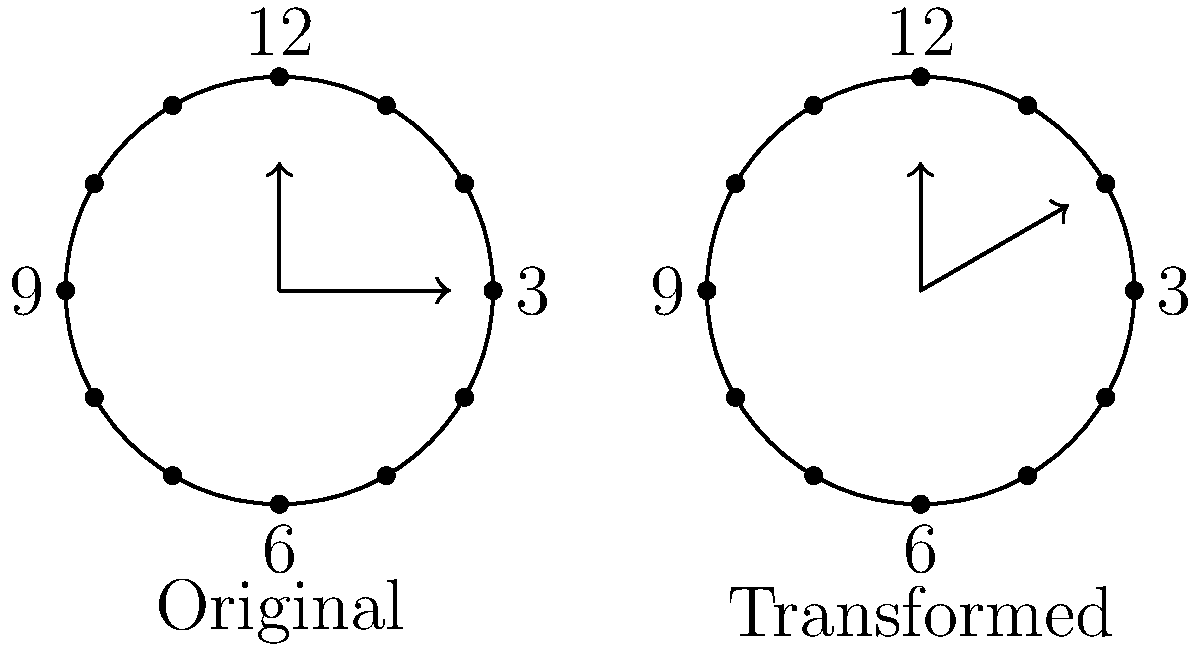As a radio broadcaster covering multiple time zones, you need to adjust your clock for different broadcast regions. If the original clock face on the left represents your local time, and you need to broadcast to a region 2 hours ahead, how would you describe the transformation applied to the hour hand to create the clock face on the right? Express your answer in terms of rotation angle and direction. To solve this problem, let's follow these steps:

1. Observe the original clock face (left) and the transformed clock face (right).
2. Note that the hour hand on the original clock points to 3 (quarter past the hour).
3. On the transformed clock, the hour hand has moved clockwise.
4. To determine the angle of rotation:
   - Each hour on the clock face represents 30° (360° ÷ 12 hours = 30° per hour).
   - The question states the new time zone is 2 hours ahead.
   - Therefore, the rotation angle is: 2 hours × 30° per hour = 60°.
5. The direction of rotation is clockwise, as the hand has moved forward in time.

Thus, the transformation applied to the hour hand is a 60° clockwise rotation.
Answer: 60° clockwise rotation 